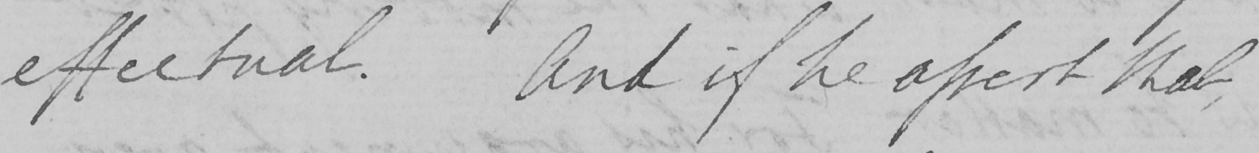What text is written in this handwritten line? effectual . And if he assert that , 